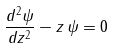Convert formula to latex. <formula><loc_0><loc_0><loc_500><loc_500>\frac { d ^ { 2 } \psi } { d z ^ { 2 } } - z \, \psi = 0</formula> 